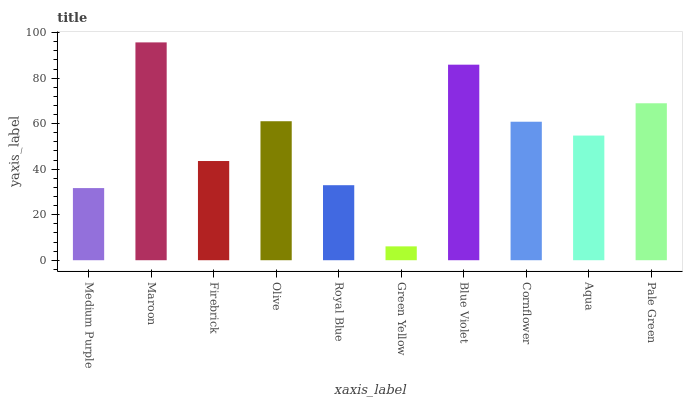Is Green Yellow the minimum?
Answer yes or no. Yes. Is Maroon the maximum?
Answer yes or no. Yes. Is Firebrick the minimum?
Answer yes or no. No. Is Firebrick the maximum?
Answer yes or no. No. Is Maroon greater than Firebrick?
Answer yes or no. Yes. Is Firebrick less than Maroon?
Answer yes or no. Yes. Is Firebrick greater than Maroon?
Answer yes or no. No. Is Maroon less than Firebrick?
Answer yes or no. No. Is Cornflower the high median?
Answer yes or no. Yes. Is Aqua the low median?
Answer yes or no. Yes. Is Maroon the high median?
Answer yes or no. No. Is Medium Purple the low median?
Answer yes or no. No. 